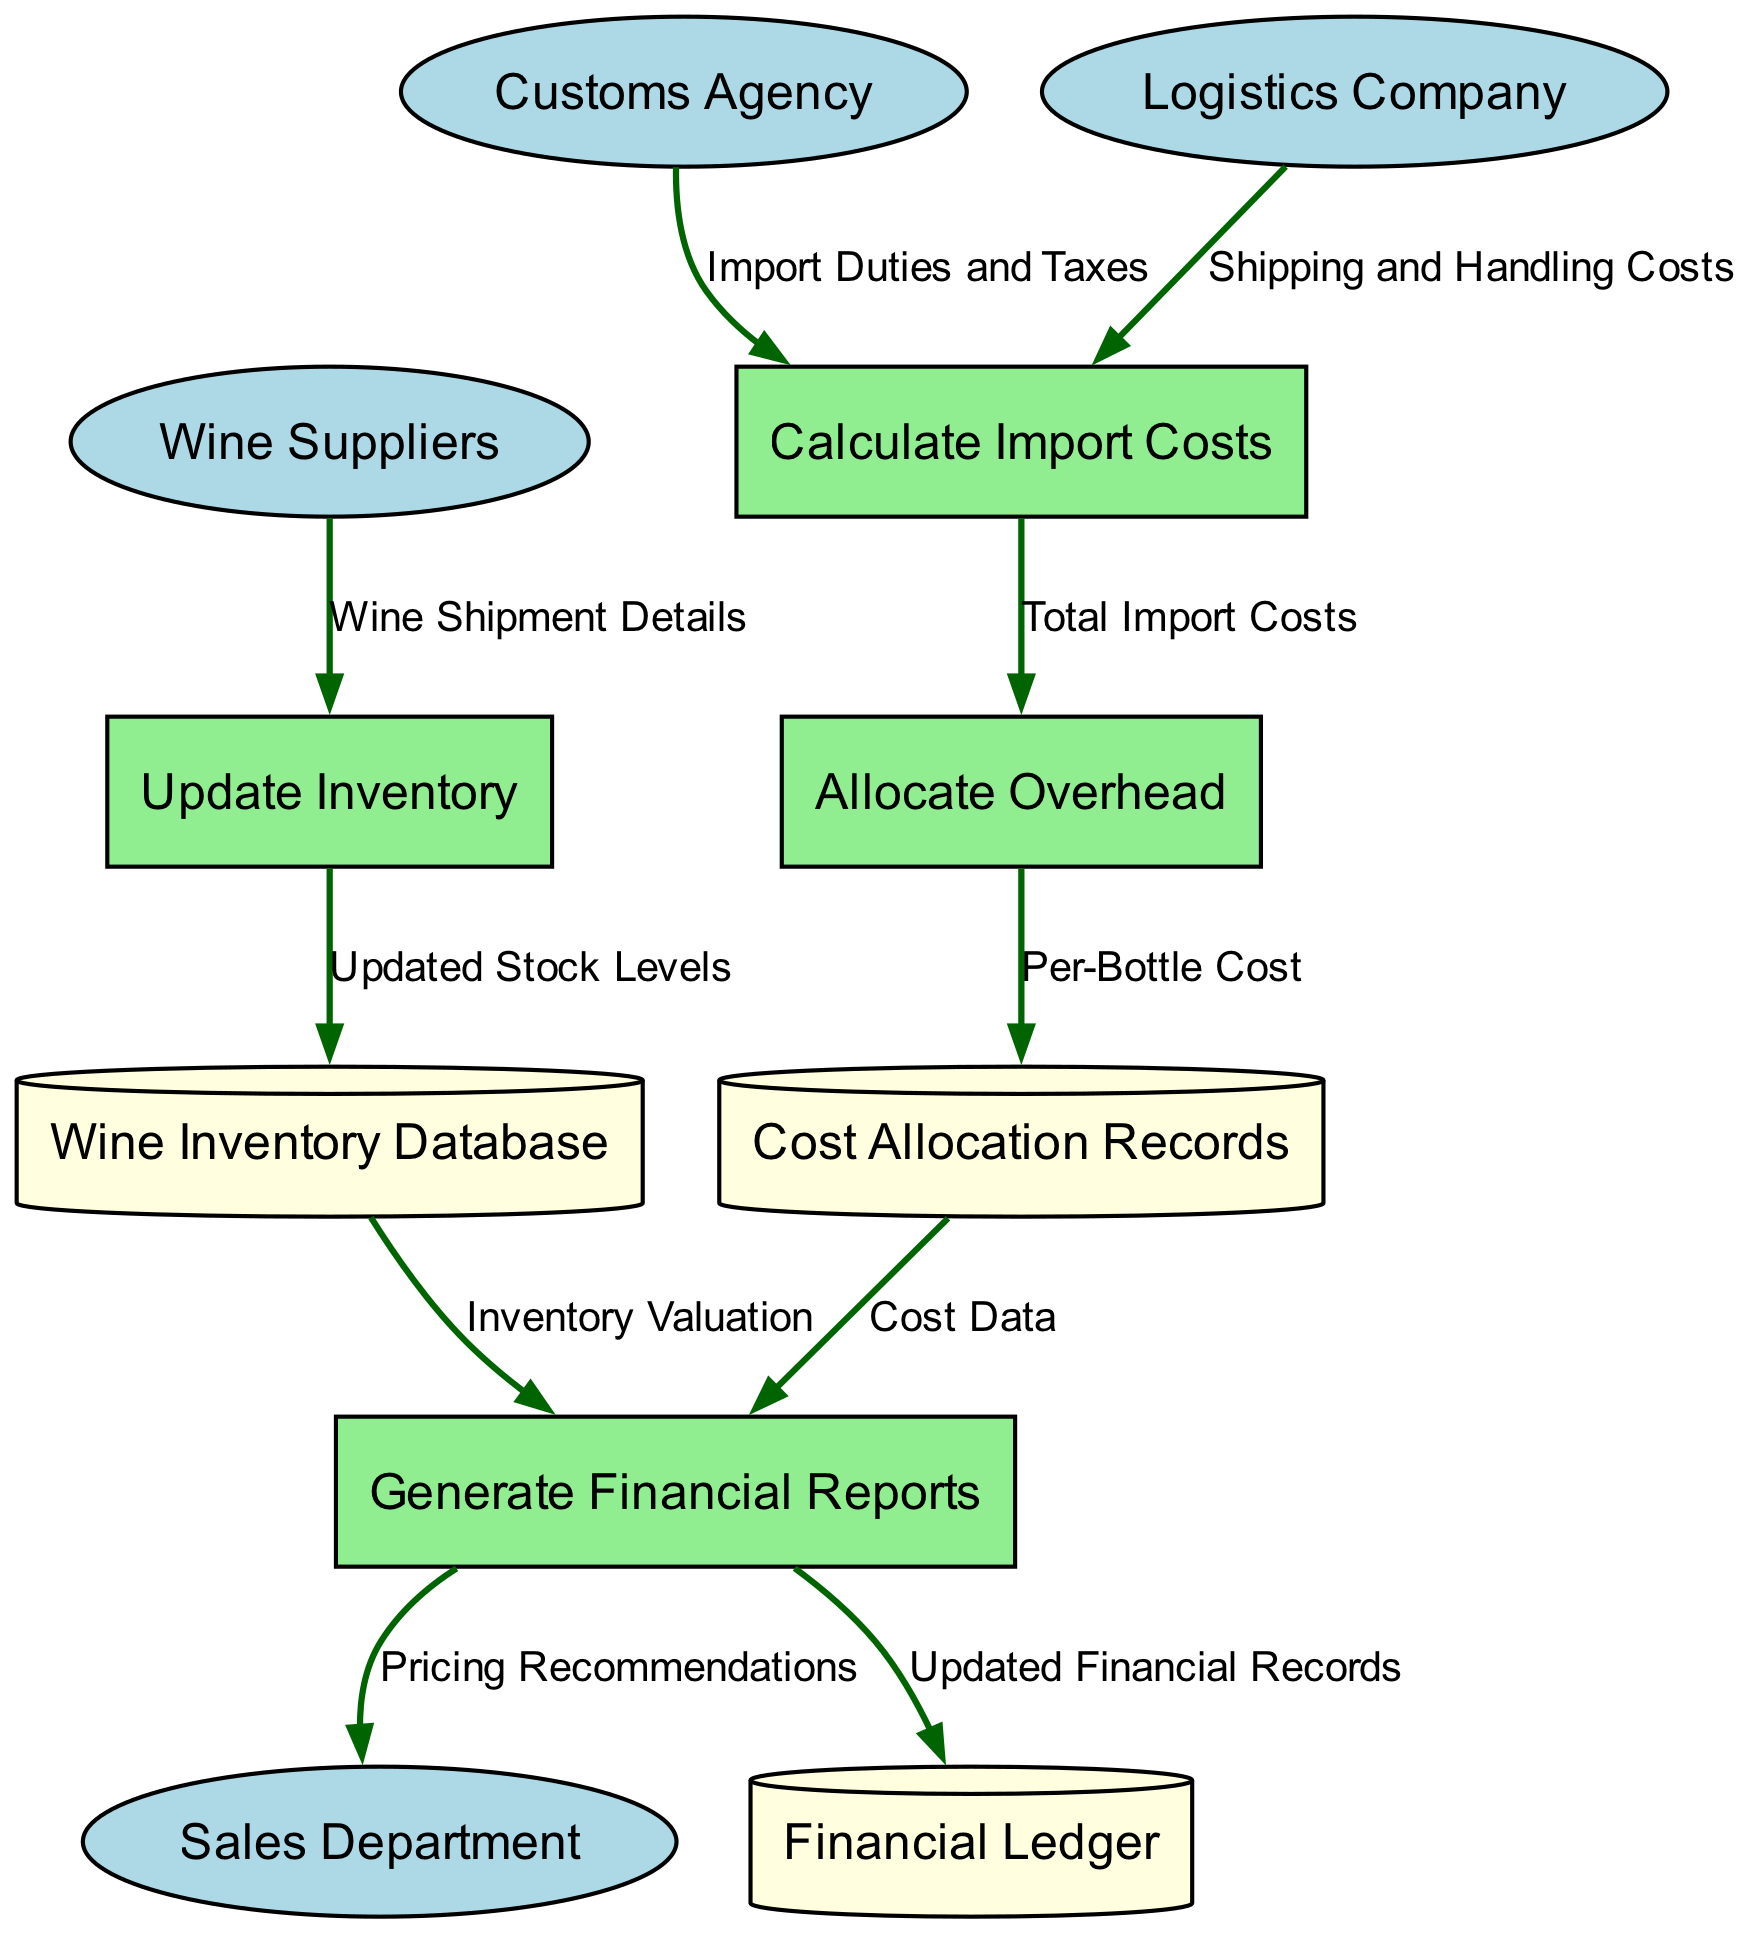What are the external entities in the diagram? The diagram lists four external entities: Wine Suppliers, Customs Agency, Logistics Company, and Sales Department. These entities interact with the internal processes to contribute to the workflow.
Answer: Wine Suppliers, Customs Agency, Logistics Company, Sales Department How many processes are represented in the diagram? The diagram contains four processes: Update Inventory, Calculate Import Costs, Allocate Overhead, and Generate Financial Reports. Each process has a specific function in managing wine inventory and costs.
Answer: 4 Which process receives the "Wine Shipment Details"? The "Update Inventory" process receives the "Wine Shipment Details" from the Wine Suppliers. This flow indicates that the inventory is updated based on shipments received.
Answer: Update Inventory What data store is linked to the "Generate Financial Reports" process? There are two data stores linked to the "Generate Financial Reports" process: Wine Inventory Database and Cost Allocation Records. Both are used to gather important data for report generation.
Answer: Wine Inventory Database, Cost Allocation Records What is the data flow from "Calculate Import Costs" to "Allocate Overhead"? The data flow from "Calculate Import Costs" to "Allocate Overhead" is labeled "Total Import Costs." This indicates that the total costs calculated during the import process are allocated as overhead for accounting purposes.
Answer: Total Import Costs Which external entity provides "Import Duties and Taxes"? The "Customs Agency" provides "Import Duties and Taxes" to the "Calculate Import Costs" process. This external data is crucial for proper cost assessment during import.
Answer: Customs Agency How many data flows are depicted between the processes and external entities? There are six data flows depicted between the processes and external entities: four are incoming flows from external entities, and two are internal flows between processes. Counting each connection provides insight into the interaction within the diagram.
Answer: 6 What is the output of the "Generate Financial Reports" process? The "Generate Financial Reports" process outputs both updated financial records to the Financial Ledger and pricing recommendations to the Sales Department. This dual output reflects important financial actions following the report generation.
Answer: Updated Financial Records, Pricing Recommendations What information does the "Allocate Overhead" process provide to the "Cost Allocation Records"? The "Allocate Overhead" process provides the "Per-Bottle Cost" to the "Cost Allocation Records." This process calculates how much overhead is attributed to each bottle of wine to ensure accurate pricing and financial reporting.
Answer: Per-Bottle Cost 